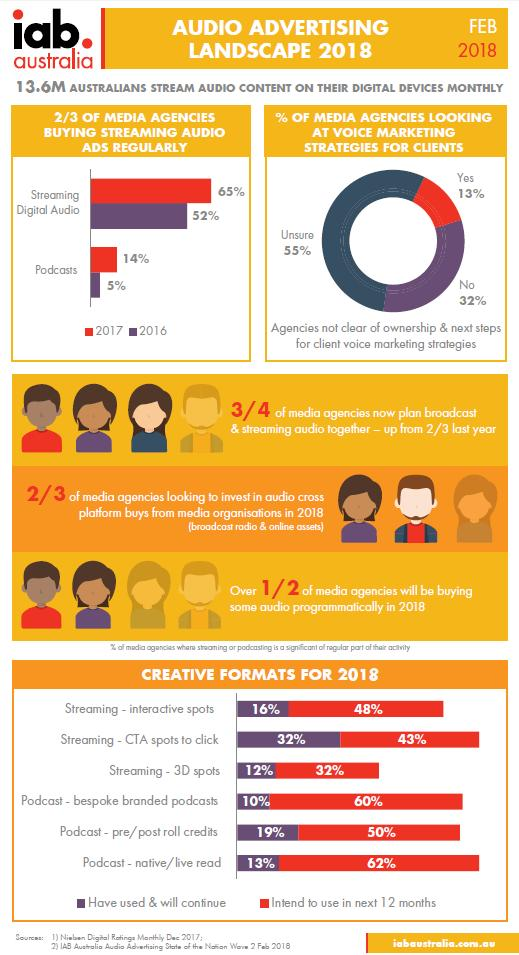Indicate a few pertinent items in this graphic. In 2017, the percentage of podcasts was 14%. Out of the 100 clients we surveyed, 13% expressed interest in using voice marketing strategies for their businesses. Thirty-two percent of clients are not using voice marketing strategies. In 2016, 52% of people were streaming digital audio. The document mentions 2018 a total of 6 times. 